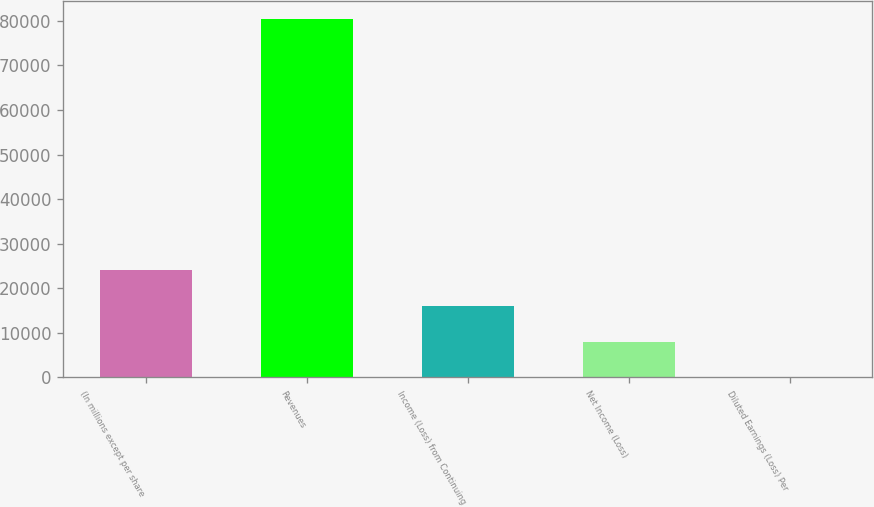Convert chart. <chart><loc_0><loc_0><loc_500><loc_500><bar_chart><fcel>(In millions except per share<fcel>Revenues<fcel>Income (Loss) from Continuing<fcel>Net Income (Loss)<fcel>Diluted Earnings (Loss) Per<nl><fcel>24154.8<fcel>80514.6<fcel>16103.4<fcel>8051.94<fcel>0.53<nl></chart> 